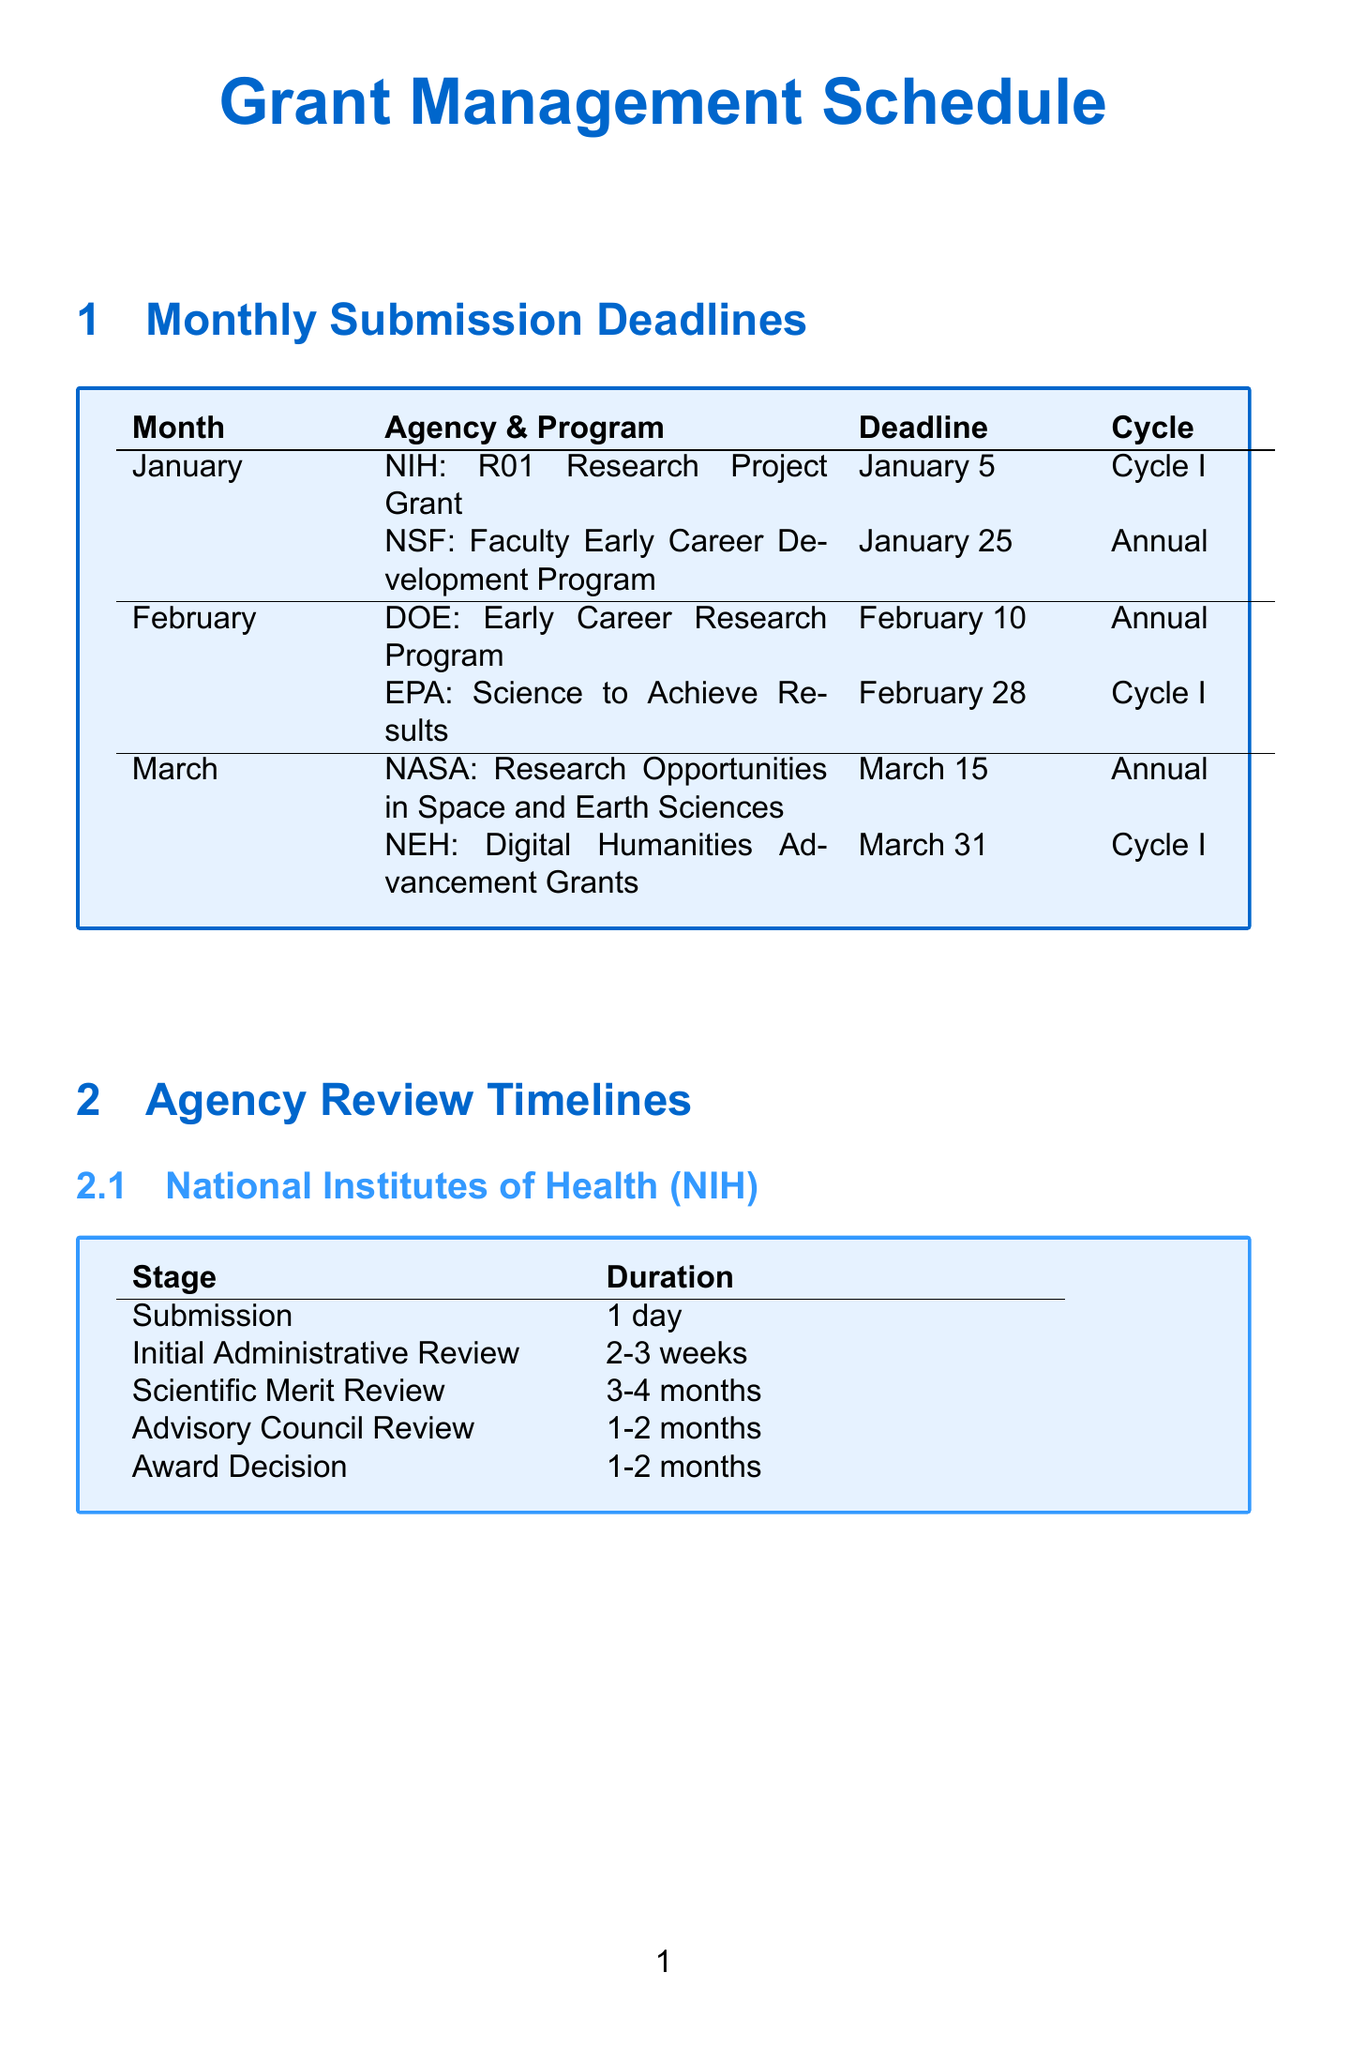What is the deadline for the NIH R01 Research Project Grant? The deadline for the NIH R01 Research Project Grant is specified in the document as January 5.
Answer: January 5 Which program has a deadline on February 28? The document lists the Environmental Protection Agency's Science to Achieve Results (STAR) program as having a deadline on February 28.
Answer: Science to Achieve Results (STAR) How long does the Scientific Merit Review stage take for NIH? The duration for the Scientific Merit Review stage according to the document is between 3 to 4 months.
Answer: 3-4 months What is the funding cycle for the NSF CAREER program? The document indicates that the NSF Faculty Early Career Development Program (CAREER) has an annual funding cycle.
Answer: Annual How frequently are financial reports required post-award? The document states that financial reports are required quarterly after the award has been made.
Answer: Quarterly What are the evaluation criteria used by NSF? The document provides the evaluation criteria for NSF, which include Intellectual Merit and Broader Impacts.
Answer: Intellectual Merit, Broader Impacts What stage follows the Initial Administrative Review for NIH? According to the document, the stage that follows the Initial Administrative Review is the Scientific Merit Review.
Answer: Scientific Merit Review Which agency has a program called Digital Humanities Advancement Grants? The document specifies that the National Endowment for the Humanities (NEH) has the Digital Humanities Advancement Grants program.
Answer: National Endowment for the Humanities (NEH) What is the frequency of progress reports in post-award monitoring? The document indicates that progress reports are required annually following the award.
Answer: Annual 